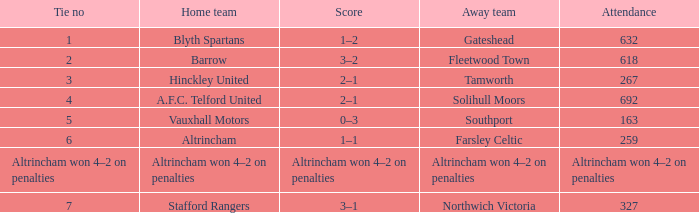What home team had 2 ties? Barrow. 